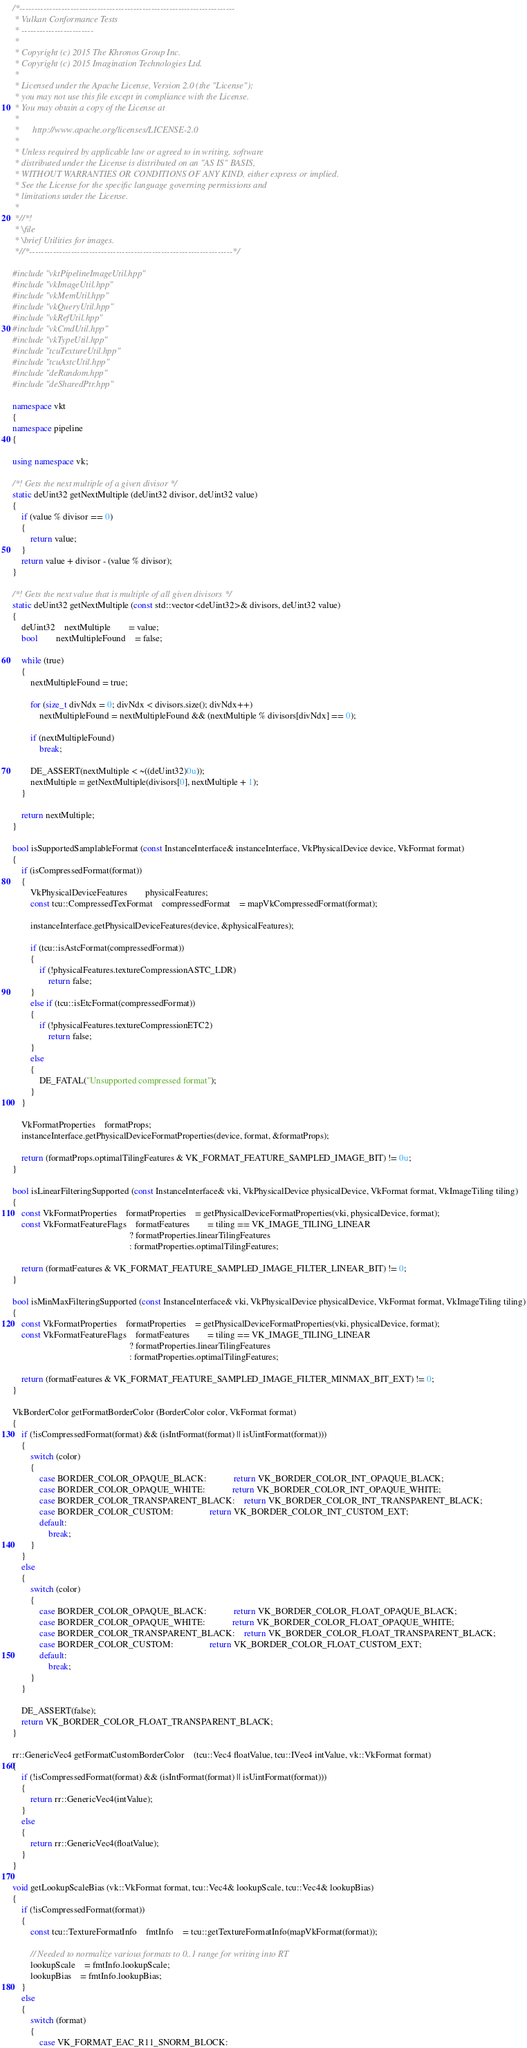Convert code to text. <code><loc_0><loc_0><loc_500><loc_500><_C++_>/*------------------------------------------------------------------------
 * Vulkan Conformance Tests
 * ------------------------
 *
 * Copyright (c) 2015 The Khronos Group Inc.
 * Copyright (c) 2015 Imagination Technologies Ltd.
 *
 * Licensed under the Apache License, Version 2.0 (the "License");
 * you may not use this file except in compliance with the License.
 * You may obtain a copy of the License at
 *
 *      http://www.apache.org/licenses/LICENSE-2.0
 *
 * Unless required by applicable law or agreed to in writing, software
 * distributed under the License is distributed on an "AS IS" BASIS,
 * WITHOUT WARRANTIES OR CONDITIONS OF ANY KIND, either express or implied.
 * See the License for the specific language governing permissions and
 * limitations under the License.
 *
 *//*!
 * \file
 * \brief Utilities for images.
 *//*--------------------------------------------------------------------*/

#include "vktPipelineImageUtil.hpp"
#include "vkImageUtil.hpp"
#include "vkMemUtil.hpp"
#include "vkQueryUtil.hpp"
#include "vkRefUtil.hpp"
#include "vkCmdUtil.hpp"
#include "vkTypeUtil.hpp"
#include "tcuTextureUtil.hpp"
#include "tcuAstcUtil.hpp"
#include "deRandom.hpp"
#include "deSharedPtr.hpp"

namespace vkt
{
namespace pipeline
{

using namespace vk;

/*! Gets the next multiple of a given divisor */
static deUint32 getNextMultiple (deUint32 divisor, deUint32 value)
{
	if (value % divisor == 0)
	{
		return value;
	}
	return value + divisor - (value % divisor);
}

/*! Gets the next value that is multiple of all given divisors */
static deUint32 getNextMultiple (const std::vector<deUint32>& divisors, deUint32 value)
{
	deUint32	nextMultiple		= value;
	bool		nextMultipleFound	= false;

	while (true)
	{
		nextMultipleFound = true;

		for (size_t divNdx = 0; divNdx < divisors.size(); divNdx++)
			nextMultipleFound = nextMultipleFound && (nextMultiple % divisors[divNdx] == 0);

		if (nextMultipleFound)
			break;

		DE_ASSERT(nextMultiple < ~((deUint32)0u));
		nextMultiple = getNextMultiple(divisors[0], nextMultiple + 1);
	}

	return nextMultiple;
}

bool isSupportedSamplableFormat (const InstanceInterface& instanceInterface, VkPhysicalDevice device, VkFormat format)
{
	if (isCompressedFormat(format))
	{
		VkPhysicalDeviceFeatures		physicalFeatures;
		const tcu::CompressedTexFormat	compressedFormat	= mapVkCompressedFormat(format);

		instanceInterface.getPhysicalDeviceFeatures(device, &physicalFeatures);

		if (tcu::isAstcFormat(compressedFormat))
		{
			if (!physicalFeatures.textureCompressionASTC_LDR)
				return false;
		}
		else if (tcu::isEtcFormat(compressedFormat))
		{
			if (!physicalFeatures.textureCompressionETC2)
				return false;
		}
		else
		{
			DE_FATAL("Unsupported compressed format");
		}
	}

	VkFormatProperties	formatProps;
	instanceInterface.getPhysicalDeviceFormatProperties(device, format, &formatProps);

	return (formatProps.optimalTilingFeatures & VK_FORMAT_FEATURE_SAMPLED_IMAGE_BIT) != 0u;
}

bool isLinearFilteringSupported (const InstanceInterface& vki, VkPhysicalDevice physicalDevice, VkFormat format, VkImageTiling tiling)
{
	const VkFormatProperties	formatProperties	= getPhysicalDeviceFormatProperties(vki, physicalDevice, format);
	const VkFormatFeatureFlags	formatFeatures		= tiling == VK_IMAGE_TILING_LINEAR
													? formatProperties.linearTilingFeatures
													: formatProperties.optimalTilingFeatures;

	return (formatFeatures & VK_FORMAT_FEATURE_SAMPLED_IMAGE_FILTER_LINEAR_BIT) != 0;
}

bool isMinMaxFilteringSupported (const InstanceInterface& vki, VkPhysicalDevice physicalDevice, VkFormat format, VkImageTiling tiling)
{
	const VkFormatProperties	formatProperties	= getPhysicalDeviceFormatProperties(vki, physicalDevice, format);
	const VkFormatFeatureFlags	formatFeatures		= tiling == VK_IMAGE_TILING_LINEAR
													? formatProperties.linearTilingFeatures
													: formatProperties.optimalTilingFeatures;

	return (formatFeatures & VK_FORMAT_FEATURE_SAMPLED_IMAGE_FILTER_MINMAX_BIT_EXT) != 0;
}

VkBorderColor getFormatBorderColor (BorderColor color, VkFormat format)
{
	if (!isCompressedFormat(format) && (isIntFormat(format) || isUintFormat(format)))
	{
		switch (color)
		{
			case BORDER_COLOR_OPAQUE_BLACK:			return VK_BORDER_COLOR_INT_OPAQUE_BLACK;
			case BORDER_COLOR_OPAQUE_WHITE:			return VK_BORDER_COLOR_INT_OPAQUE_WHITE;
			case BORDER_COLOR_TRANSPARENT_BLACK:	return VK_BORDER_COLOR_INT_TRANSPARENT_BLACK;
			case BORDER_COLOR_CUSTOM:				return VK_BORDER_COLOR_INT_CUSTOM_EXT;
			default:
				break;
		}
	}
	else
	{
		switch (color)
		{
			case BORDER_COLOR_OPAQUE_BLACK:			return VK_BORDER_COLOR_FLOAT_OPAQUE_BLACK;
			case BORDER_COLOR_OPAQUE_WHITE:			return VK_BORDER_COLOR_FLOAT_OPAQUE_WHITE;
			case BORDER_COLOR_TRANSPARENT_BLACK:	return VK_BORDER_COLOR_FLOAT_TRANSPARENT_BLACK;
			case BORDER_COLOR_CUSTOM:				return VK_BORDER_COLOR_FLOAT_CUSTOM_EXT;
			default:
				break;
		}
	}

	DE_ASSERT(false);
	return VK_BORDER_COLOR_FLOAT_TRANSPARENT_BLACK;
}

rr::GenericVec4 getFormatCustomBorderColor	(tcu::Vec4 floatValue, tcu::IVec4 intValue, vk::VkFormat format)
{
	if (!isCompressedFormat(format) && (isIntFormat(format) || isUintFormat(format)))
	{
		return rr::GenericVec4(intValue);
	}
	else
	{
		return rr::GenericVec4(floatValue);
	}
}

void getLookupScaleBias (vk::VkFormat format, tcu::Vec4& lookupScale, tcu::Vec4& lookupBias)
{
	if (!isCompressedFormat(format))
	{
		const tcu::TextureFormatInfo	fmtInfo	= tcu::getTextureFormatInfo(mapVkFormat(format));

		// Needed to normalize various formats to 0..1 range for writing into RT
		lookupScale	= fmtInfo.lookupScale;
		lookupBias	= fmtInfo.lookupBias;
	}
	else
	{
		switch (format)
		{
			case VK_FORMAT_EAC_R11_SNORM_BLOCK:</code> 